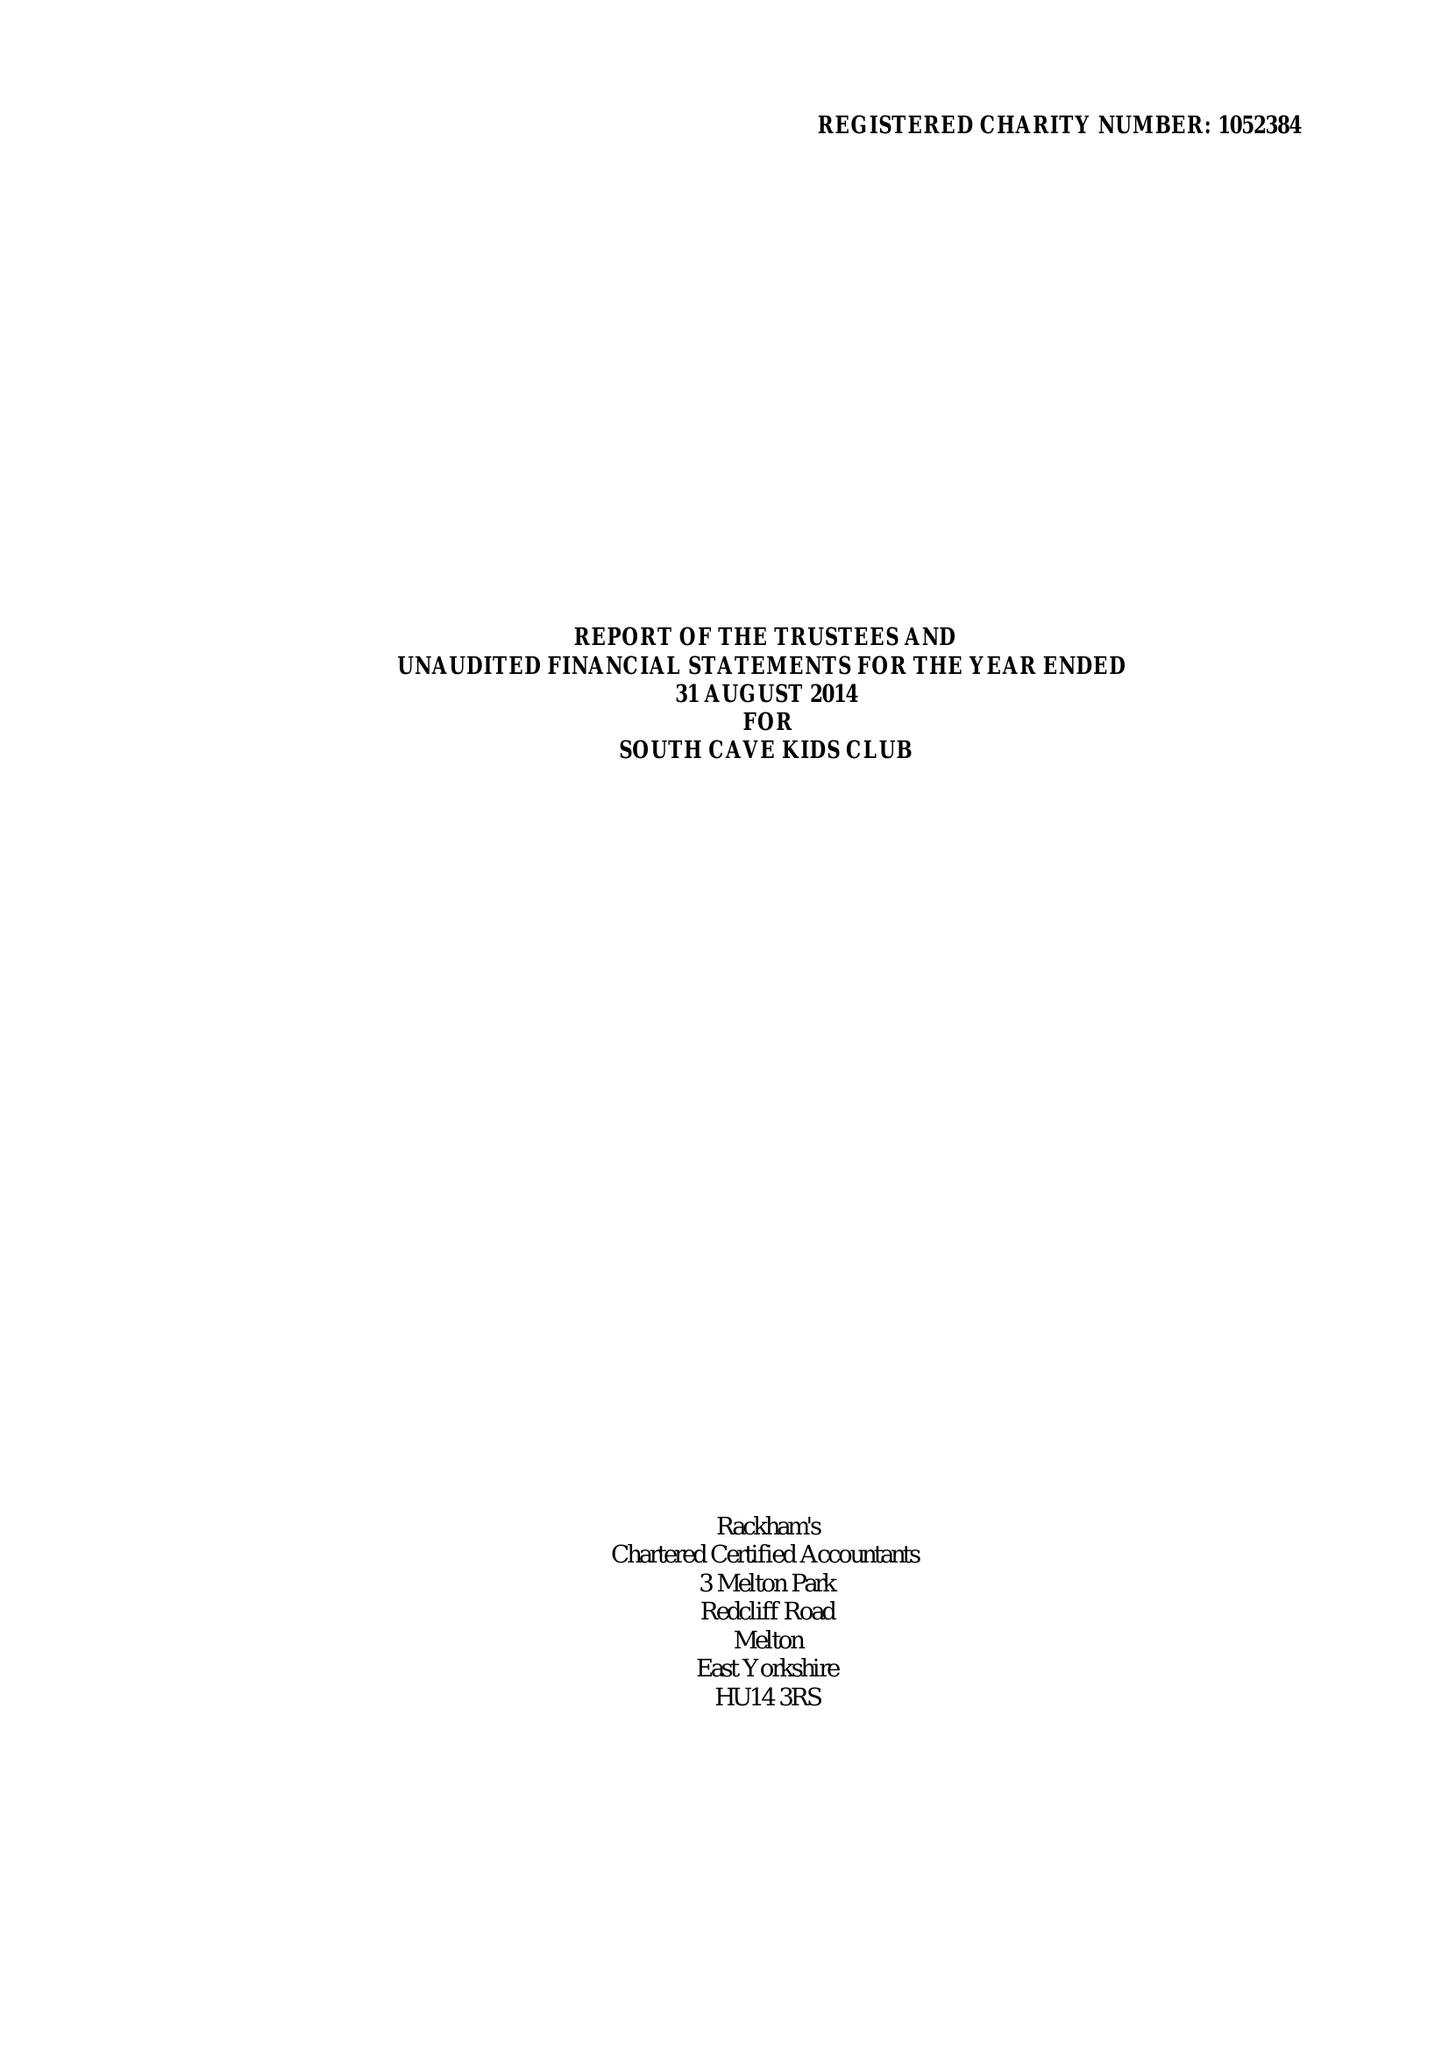What is the value for the charity_name?
Answer the question using a single word or phrase. South Cave Kids Club 